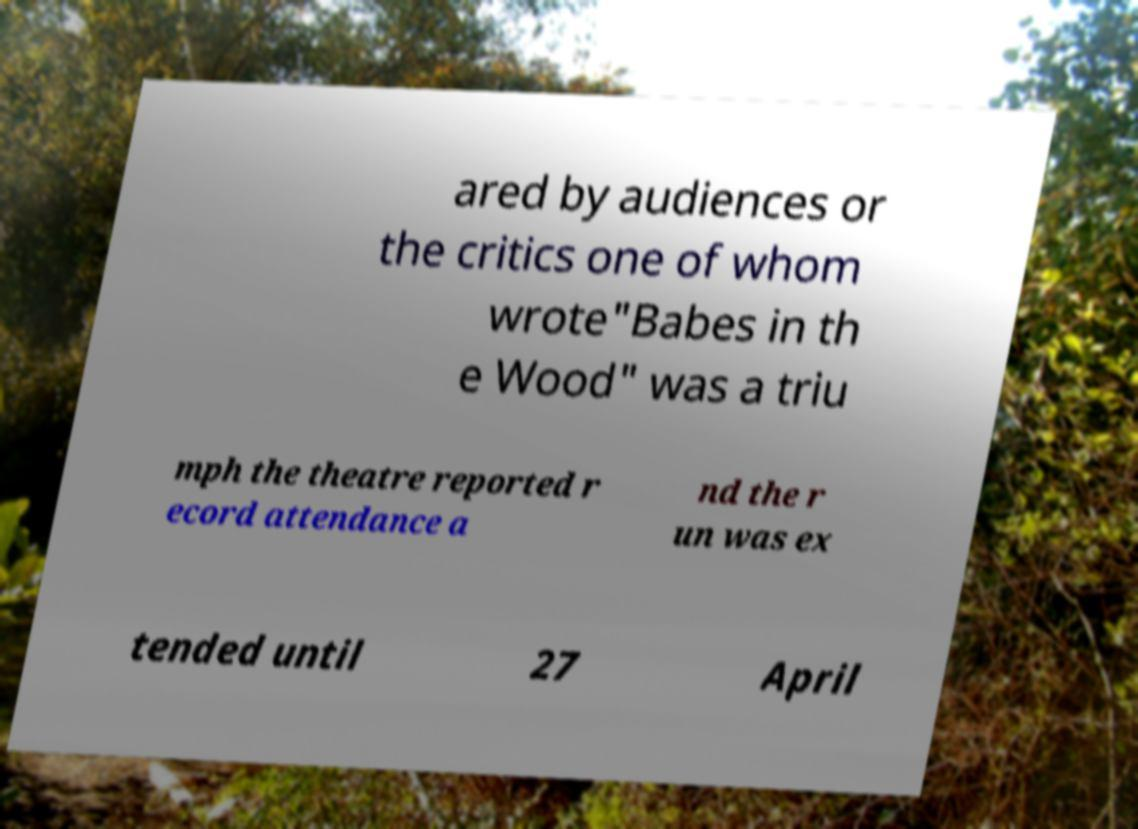What messages or text are displayed in this image? I need them in a readable, typed format. ared by audiences or the critics one of whom wrote"Babes in th e Wood" was a triu mph the theatre reported r ecord attendance a nd the r un was ex tended until 27 April 